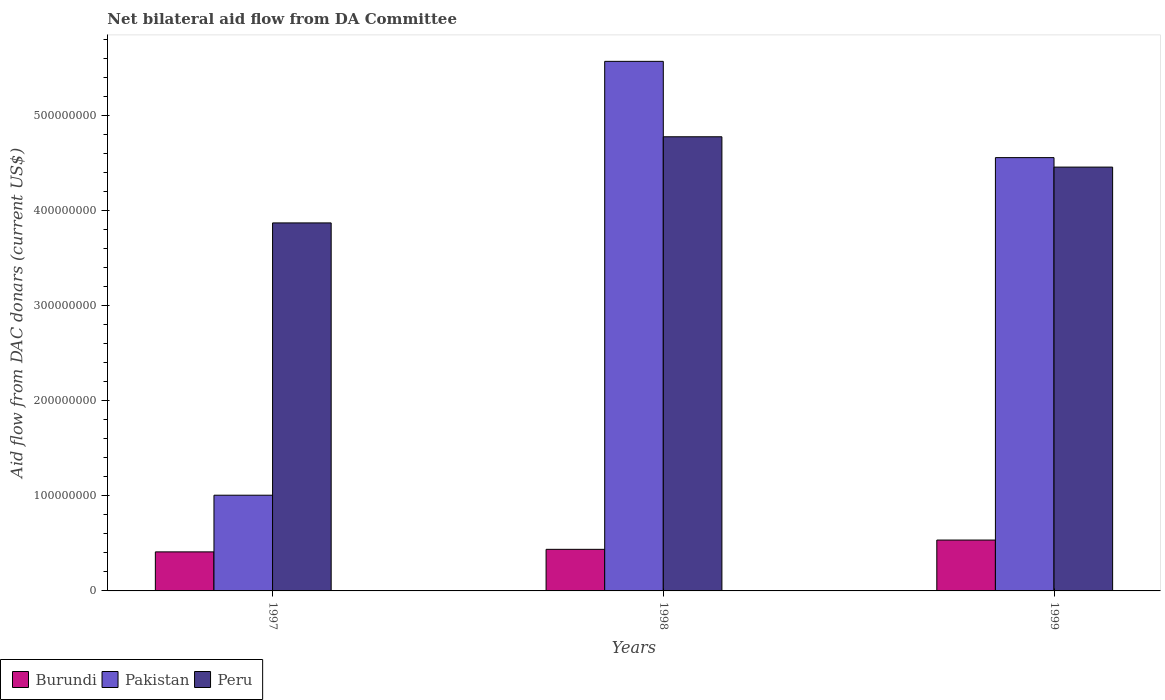How many groups of bars are there?
Offer a very short reply. 3. How many bars are there on the 1st tick from the left?
Your response must be concise. 3. How many bars are there on the 2nd tick from the right?
Your answer should be very brief. 3. What is the label of the 1st group of bars from the left?
Keep it short and to the point. 1997. In how many cases, is the number of bars for a given year not equal to the number of legend labels?
Provide a succinct answer. 0. What is the aid flow in in Peru in 1997?
Offer a very short reply. 3.87e+08. Across all years, what is the maximum aid flow in in Pakistan?
Ensure brevity in your answer.  5.57e+08. Across all years, what is the minimum aid flow in in Peru?
Make the answer very short. 3.87e+08. In which year was the aid flow in in Pakistan maximum?
Ensure brevity in your answer.  1998. In which year was the aid flow in in Peru minimum?
Make the answer very short. 1997. What is the total aid flow in in Pakistan in the graph?
Make the answer very short. 1.11e+09. What is the difference between the aid flow in in Pakistan in 1997 and that in 1999?
Offer a terse response. -3.55e+08. What is the difference between the aid flow in in Pakistan in 1997 and the aid flow in in Peru in 1999?
Offer a terse response. -3.45e+08. What is the average aid flow in in Burundi per year?
Provide a short and direct response. 4.61e+07. In the year 1997, what is the difference between the aid flow in in Burundi and aid flow in in Peru?
Keep it short and to the point. -3.46e+08. In how many years, is the aid flow in in Peru greater than 320000000 US$?
Your answer should be very brief. 3. What is the ratio of the aid flow in in Pakistan in 1998 to that in 1999?
Keep it short and to the point. 1.22. Is the aid flow in in Peru in 1998 less than that in 1999?
Provide a short and direct response. No. What is the difference between the highest and the second highest aid flow in in Peru?
Keep it short and to the point. 3.19e+07. What is the difference between the highest and the lowest aid flow in in Pakistan?
Provide a succinct answer. 4.56e+08. In how many years, is the aid flow in in Peru greater than the average aid flow in in Peru taken over all years?
Your answer should be compact. 2. What does the 3rd bar from the left in 1997 represents?
Make the answer very short. Peru. Is it the case that in every year, the sum of the aid flow in in Burundi and aid flow in in Pakistan is greater than the aid flow in in Peru?
Your answer should be compact. No. How many bars are there?
Your answer should be compact. 9. Are all the bars in the graph horizontal?
Offer a terse response. No. How many years are there in the graph?
Your response must be concise. 3. What is the difference between two consecutive major ticks on the Y-axis?
Give a very brief answer. 1.00e+08. Are the values on the major ticks of Y-axis written in scientific E-notation?
Your answer should be very brief. No. How many legend labels are there?
Offer a terse response. 3. How are the legend labels stacked?
Your answer should be very brief. Horizontal. What is the title of the graph?
Make the answer very short. Net bilateral aid flow from DA Committee. What is the label or title of the X-axis?
Your answer should be compact. Years. What is the label or title of the Y-axis?
Make the answer very short. Aid flow from DAC donars (current US$). What is the Aid flow from DAC donars (current US$) of Burundi in 1997?
Offer a terse response. 4.10e+07. What is the Aid flow from DAC donars (current US$) of Pakistan in 1997?
Your answer should be compact. 1.01e+08. What is the Aid flow from DAC donars (current US$) of Peru in 1997?
Make the answer very short. 3.87e+08. What is the Aid flow from DAC donars (current US$) in Burundi in 1998?
Your response must be concise. 4.37e+07. What is the Aid flow from DAC donars (current US$) in Pakistan in 1998?
Your response must be concise. 5.57e+08. What is the Aid flow from DAC donars (current US$) in Peru in 1998?
Make the answer very short. 4.77e+08. What is the Aid flow from DAC donars (current US$) in Burundi in 1999?
Your response must be concise. 5.35e+07. What is the Aid flow from DAC donars (current US$) in Pakistan in 1999?
Keep it short and to the point. 4.56e+08. What is the Aid flow from DAC donars (current US$) of Peru in 1999?
Provide a succinct answer. 4.46e+08. Across all years, what is the maximum Aid flow from DAC donars (current US$) of Burundi?
Provide a short and direct response. 5.35e+07. Across all years, what is the maximum Aid flow from DAC donars (current US$) in Pakistan?
Your response must be concise. 5.57e+08. Across all years, what is the maximum Aid flow from DAC donars (current US$) of Peru?
Keep it short and to the point. 4.77e+08. Across all years, what is the minimum Aid flow from DAC donars (current US$) of Burundi?
Ensure brevity in your answer.  4.10e+07. Across all years, what is the minimum Aid flow from DAC donars (current US$) in Pakistan?
Keep it short and to the point. 1.01e+08. Across all years, what is the minimum Aid flow from DAC donars (current US$) of Peru?
Keep it short and to the point. 3.87e+08. What is the total Aid flow from DAC donars (current US$) in Burundi in the graph?
Provide a succinct answer. 1.38e+08. What is the total Aid flow from DAC donars (current US$) of Pakistan in the graph?
Make the answer very short. 1.11e+09. What is the total Aid flow from DAC donars (current US$) of Peru in the graph?
Provide a succinct answer. 1.31e+09. What is the difference between the Aid flow from DAC donars (current US$) in Burundi in 1997 and that in 1998?
Make the answer very short. -2.68e+06. What is the difference between the Aid flow from DAC donars (current US$) in Pakistan in 1997 and that in 1998?
Provide a succinct answer. -4.56e+08. What is the difference between the Aid flow from DAC donars (current US$) of Peru in 1997 and that in 1998?
Your response must be concise. -9.06e+07. What is the difference between the Aid flow from DAC donars (current US$) of Burundi in 1997 and that in 1999?
Your response must be concise. -1.24e+07. What is the difference between the Aid flow from DAC donars (current US$) of Pakistan in 1997 and that in 1999?
Your response must be concise. -3.55e+08. What is the difference between the Aid flow from DAC donars (current US$) of Peru in 1997 and that in 1999?
Keep it short and to the point. -5.87e+07. What is the difference between the Aid flow from DAC donars (current US$) of Burundi in 1998 and that in 1999?
Offer a terse response. -9.75e+06. What is the difference between the Aid flow from DAC donars (current US$) of Pakistan in 1998 and that in 1999?
Keep it short and to the point. 1.01e+08. What is the difference between the Aid flow from DAC donars (current US$) of Peru in 1998 and that in 1999?
Ensure brevity in your answer.  3.19e+07. What is the difference between the Aid flow from DAC donars (current US$) of Burundi in 1997 and the Aid flow from DAC donars (current US$) of Pakistan in 1998?
Your answer should be compact. -5.16e+08. What is the difference between the Aid flow from DAC donars (current US$) of Burundi in 1997 and the Aid flow from DAC donars (current US$) of Peru in 1998?
Offer a very short reply. -4.36e+08. What is the difference between the Aid flow from DAC donars (current US$) of Pakistan in 1997 and the Aid flow from DAC donars (current US$) of Peru in 1998?
Offer a terse response. -3.77e+08. What is the difference between the Aid flow from DAC donars (current US$) of Burundi in 1997 and the Aid flow from DAC donars (current US$) of Pakistan in 1999?
Offer a terse response. -4.14e+08. What is the difference between the Aid flow from DAC donars (current US$) in Burundi in 1997 and the Aid flow from DAC donars (current US$) in Peru in 1999?
Make the answer very short. -4.04e+08. What is the difference between the Aid flow from DAC donars (current US$) in Pakistan in 1997 and the Aid flow from DAC donars (current US$) in Peru in 1999?
Your response must be concise. -3.45e+08. What is the difference between the Aid flow from DAC donars (current US$) in Burundi in 1998 and the Aid flow from DAC donars (current US$) in Pakistan in 1999?
Make the answer very short. -4.12e+08. What is the difference between the Aid flow from DAC donars (current US$) in Burundi in 1998 and the Aid flow from DAC donars (current US$) in Peru in 1999?
Ensure brevity in your answer.  -4.02e+08. What is the difference between the Aid flow from DAC donars (current US$) in Pakistan in 1998 and the Aid flow from DAC donars (current US$) in Peru in 1999?
Your response must be concise. 1.11e+08. What is the average Aid flow from DAC donars (current US$) of Burundi per year?
Provide a short and direct response. 4.61e+07. What is the average Aid flow from DAC donars (current US$) of Pakistan per year?
Ensure brevity in your answer.  3.71e+08. What is the average Aid flow from DAC donars (current US$) in Peru per year?
Your answer should be compact. 4.37e+08. In the year 1997, what is the difference between the Aid flow from DAC donars (current US$) of Burundi and Aid flow from DAC donars (current US$) of Pakistan?
Offer a terse response. -5.96e+07. In the year 1997, what is the difference between the Aid flow from DAC donars (current US$) of Burundi and Aid flow from DAC donars (current US$) of Peru?
Give a very brief answer. -3.46e+08. In the year 1997, what is the difference between the Aid flow from DAC donars (current US$) of Pakistan and Aid flow from DAC donars (current US$) of Peru?
Give a very brief answer. -2.86e+08. In the year 1998, what is the difference between the Aid flow from DAC donars (current US$) in Burundi and Aid flow from DAC donars (current US$) in Pakistan?
Offer a terse response. -5.13e+08. In the year 1998, what is the difference between the Aid flow from DAC donars (current US$) of Burundi and Aid flow from DAC donars (current US$) of Peru?
Give a very brief answer. -4.34e+08. In the year 1998, what is the difference between the Aid flow from DAC donars (current US$) of Pakistan and Aid flow from DAC donars (current US$) of Peru?
Provide a short and direct response. 7.93e+07. In the year 1999, what is the difference between the Aid flow from DAC donars (current US$) of Burundi and Aid flow from DAC donars (current US$) of Pakistan?
Provide a succinct answer. -4.02e+08. In the year 1999, what is the difference between the Aid flow from DAC donars (current US$) in Burundi and Aid flow from DAC donars (current US$) in Peru?
Your response must be concise. -3.92e+08. In the year 1999, what is the difference between the Aid flow from DAC donars (current US$) of Pakistan and Aid flow from DAC donars (current US$) of Peru?
Your response must be concise. 9.97e+06. What is the ratio of the Aid flow from DAC donars (current US$) in Burundi in 1997 to that in 1998?
Your answer should be compact. 0.94. What is the ratio of the Aid flow from DAC donars (current US$) of Pakistan in 1997 to that in 1998?
Offer a very short reply. 0.18. What is the ratio of the Aid flow from DAC donars (current US$) of Peru in 1997 to that in 1998?
Your answer should be compact. 0.81. What is the ratio of the Aid flow from DAC donars (current US$) in Burundi in 1997 to that in 1999?
Make the answer very short. 0.77. What is the ratio of the Aid flow from DAC donars (current US$) in Pakistan in 1997 to that in 1999?
Offer a terse response. 0.22. What is the ratio of the Aid flow from DAC donars (current US$) of Peru in 1997 to that in 1999?
Ensure brevity in your answer.  0.87. What is the ratio of the Aid flow from DAC donars (current US$) of Burundi in 1998 to that in 1999?
Provide a short and direct response. 0.82. What is the ratio of the Aid flow from DAC donars (current US$) of Pakistan in 1998 to that in 1999?
Your response must be concise. 1.22. What is the ratio of the Aid flow from DAC donars (current US$) of Peru in 1998 to that in 1999?
Your response must be concise. 1.07. What is the difference between the highest and the second highest Aid flow from DAC donars (current US$) of Burundi?
Your response must be concise. 9.75e+06. What is the difference between the highest and the second highest Aid flow from DAC donars (current US$) in Pakistan?
Offer a terse response. 1.01e+08. What is the difference between the highest and the second highest Aid flow from DAC donars (current US$) in Peru?
Your answer should be compact. 3.19e+07. What is the difference between the highest and the lowest Aid flow from DAC donars (current US$) of Burundi?
Your answer should be compact. 1.24e+07. What is the difference between the highest and the lowest Aid flow from DAC donars (current US$) of Pakistan?
Your answer should be very brief. 4.56e+08. What is the difference between the highest and the lowest Aid flow from DAC donars (current US$) in Peru?
Provide a succinct answer. 9.06e+07. 